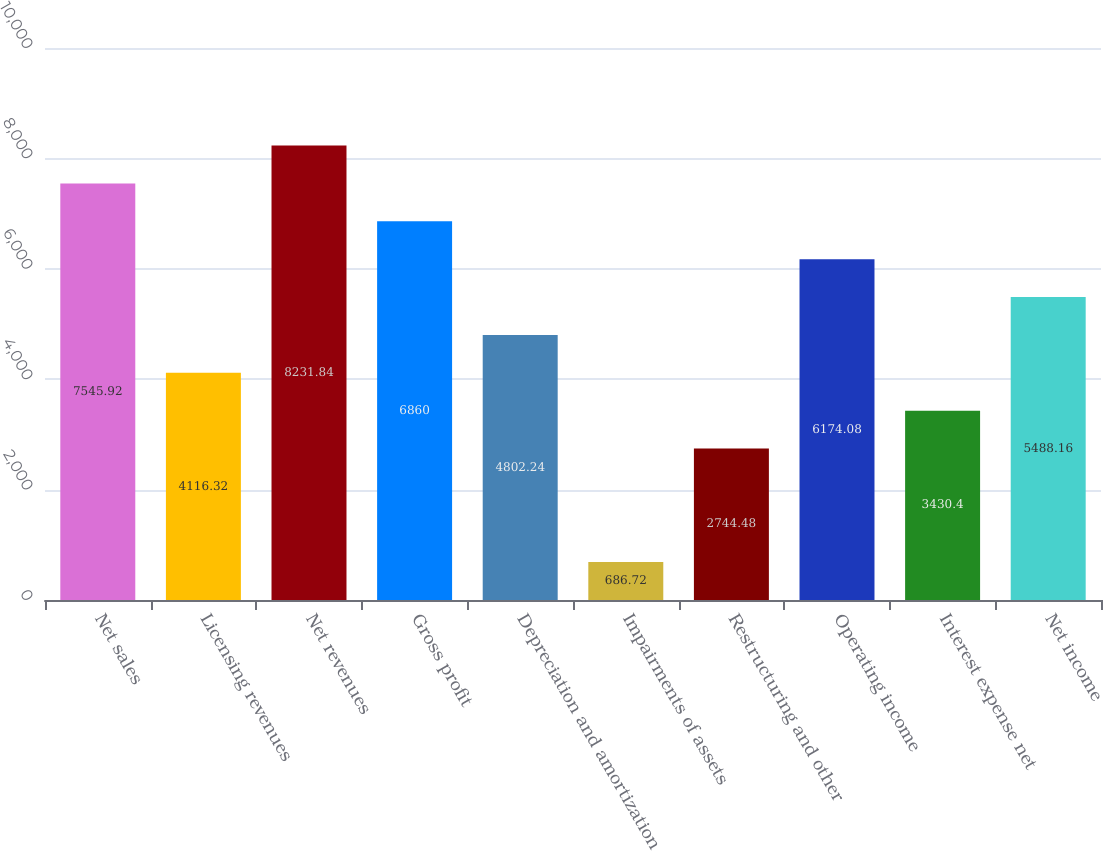<chart> <loc_0><loc_0><loc_500><loc_500><bar_chart><fcel>Net sales<fcel>Licensing revenues<fcel>Net revenues<fcel>Gross profit<fcel>Depreciation and amortization<fcel>Impairments of assets<fcel>Restructuring and other<fcel>Operating income<fcel>Interest expense net<fcel>Net income<nl><fcel>7545.92<fcel>4116.32<fcel>8231.84<fcel>6860<fcel>4802.24<fcel>686.72<fcel>2744.48<fcel>6174.08<fcel>3430.4<fcel>5488.16<nl></chart> 